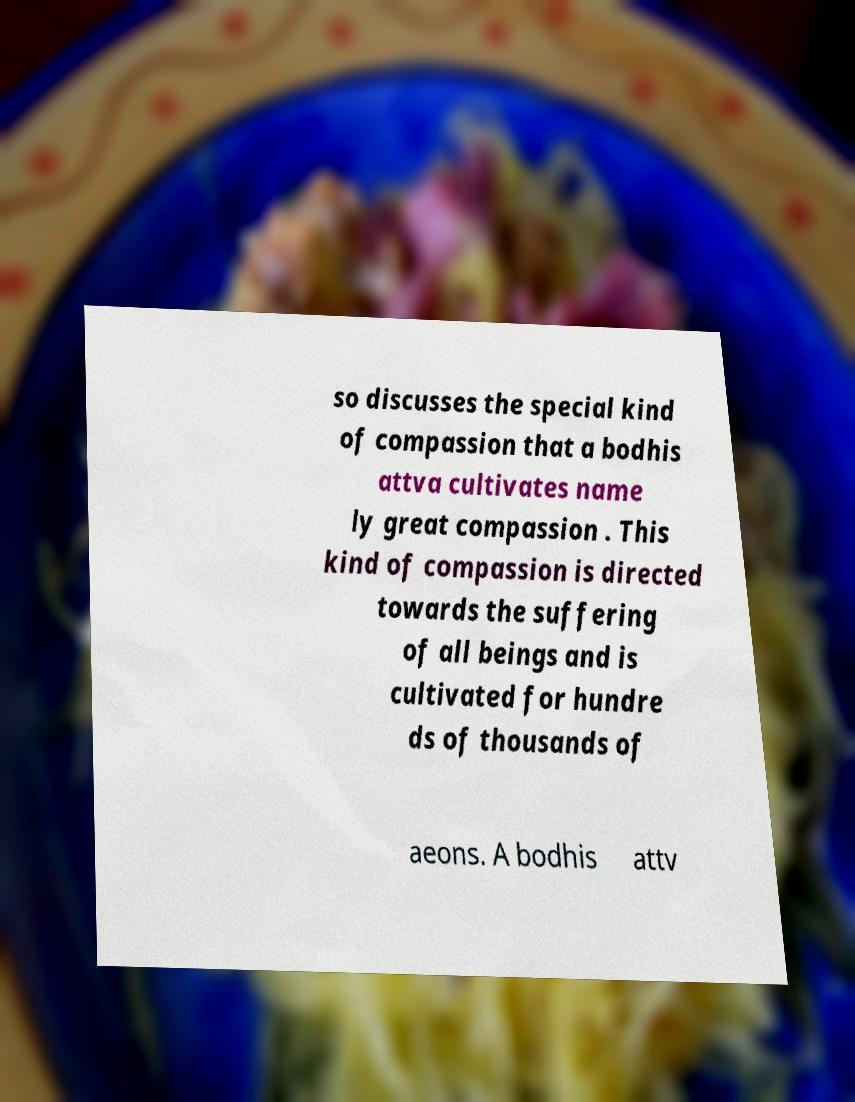Can you accurately transcribe the text from the provided image for me? so discusses the special kind of compassion that a bodhis attva cultivates name ly great compassion . This kind of compassion is directed towards the suffering of all beings and is cultivated for hundre ds of thousands of aeons. A bodhis attv 